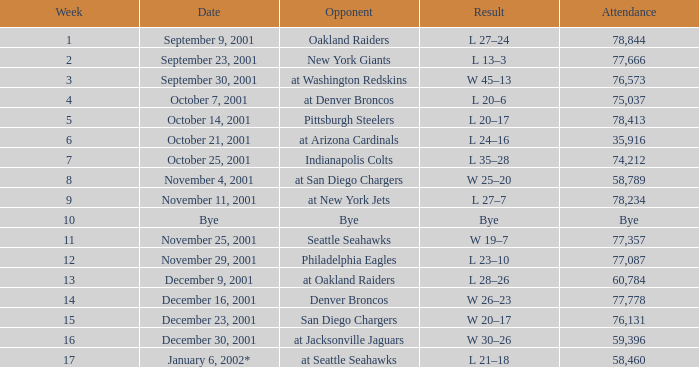Which week constitutes a bye week? 10.0. 